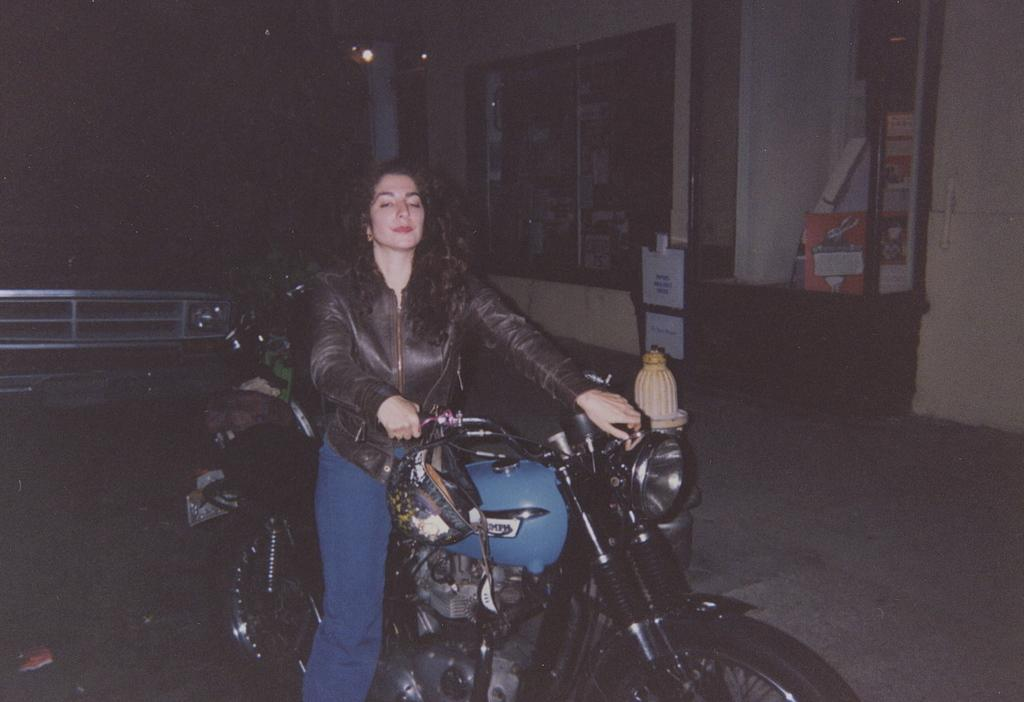What time of day was the image taken? The image was taken at night. Who is in the image? There is a woman in the image. What is the woman doing in the image? The woman is riding a bike. What can be seen in the background of the image? There is a building in the background of the image. Are there any bears visible in the image? No, there are no bears present in the image. How much dust can be seen on the bike in the image? There is no mention of dust in the image, and the bike appears to be clean. 